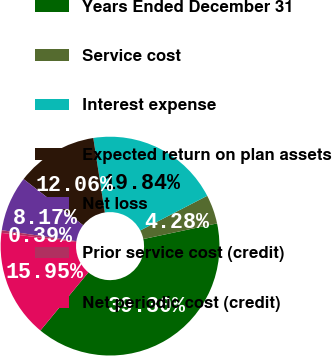<chart> <loc_0><loc_0><loc_500><loc_500><pie_chart><fcel>Years Ended December 31<fcel>Service cost<fcel>Interest expense<fcel>Expected return on plan assets<fcel>Net loss<fcel>Prior service cost (credit)<fcel>Net periodic cost (credit)<nl><fcel>39.3%<fcel>4.28%<fcel>19.84%<fcel>12.06%<fcel>8.17%<fcel>0.39%<fcel>15.95%<nl></chart> 